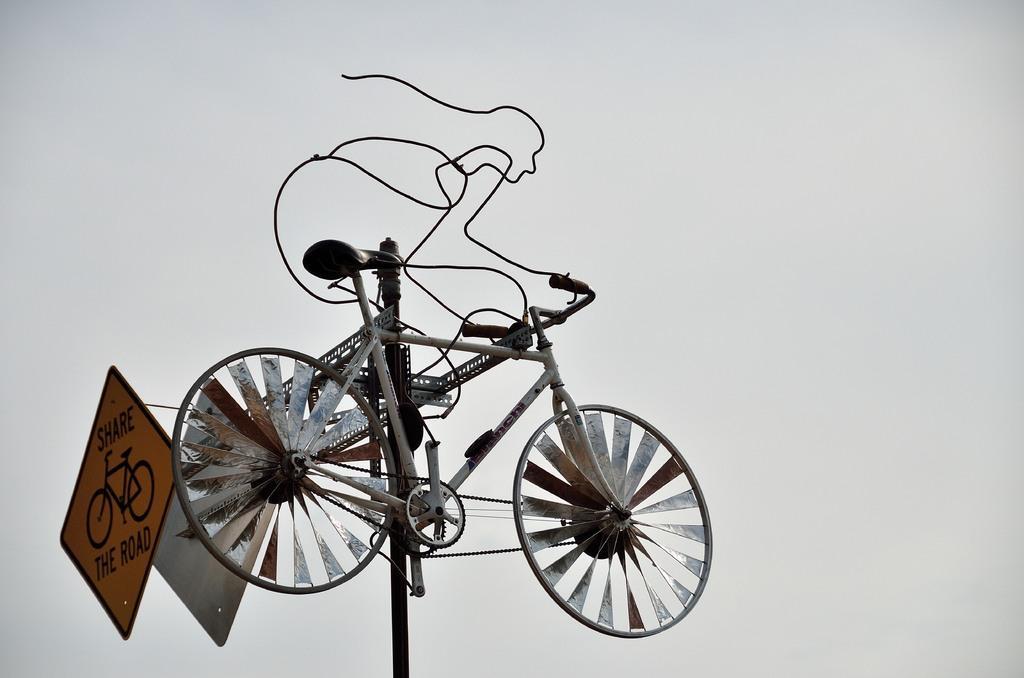Could you give a brief overview of what you see in this image? Here on a pole we can see a bicycle,two small boards and metal items. In the background there is nothing. 